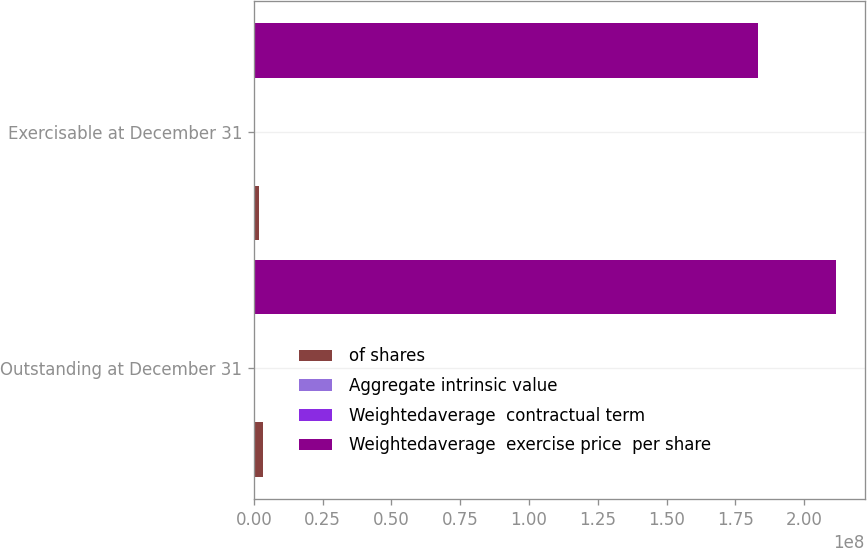Convert chart to OTSL. <chart><loc_0><loc_0><loc_500><loc_500><stacked_bar_chart><ecel><fcel>Outstanding at December 31<fcel>Exercisable at December 31<nl><fcel>of shares<fcel>3.4196e+06<fcel>1.95431e+06<nl><fcel>Aggregate intrinsic value<fcel>121.31<fcel>89.37<nl><fcel>Weightedaverage  contractual term<fcel>6.15<fcel>4.28<nl><fcel>Weightedaverage  exercise price  per share<fcel>2.1137e+08<fcel>1.83136e+08<nl></chart> 